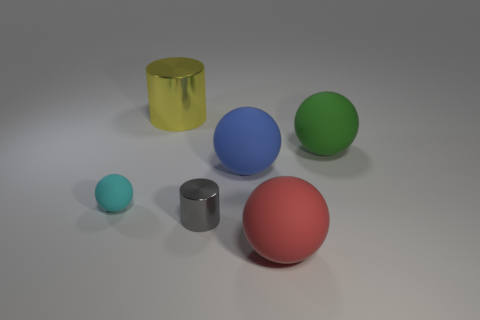Subtract all gray balls. Subtract all brown blocks. How many balls are left? 4 Add 2 tiny brown cubes. How many objects exist? 8 Subtract all balls. How many objects are left? 2 Subtract 0 blue cylinders. How many objects are left? 6 Subtract all cyan things. Subtract all red matte balls. How many objects are left? 4 Add 2 gray shiny objects. How many gray shiny objects are left? 3 Add 2 tiny things. How many tiny things exist? 4 